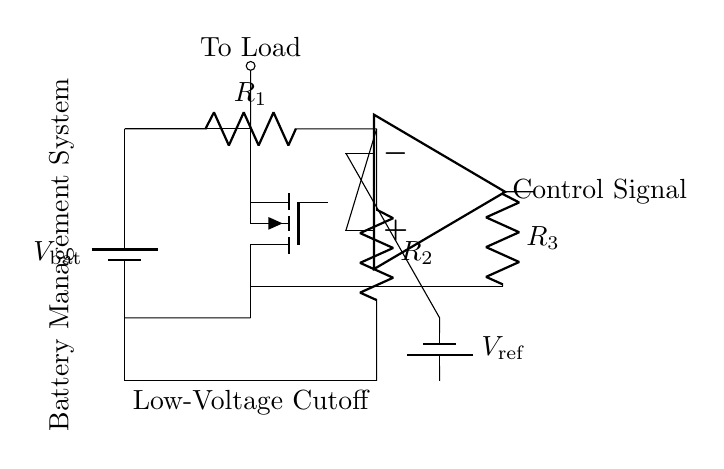What type of battery is used in this circuit? The circuit diagram indicates the use of a battery component, referred to as "V_bat," which is a generic identifier for batteries.
Answer: Battery What does R1 and R2 form together? R1 and R2 form a voltage divider, which helps to lower the voltage from the battery for comparison in the circuit.
Answer: Voltage divider What is the primary function of the mosfet in this circuit? The mosfet serves as an electronic switch that controls the connection to the load based on the voltage level detected.
Answer: Switch What signal does the op amp generate? The op amp generates a control signal based on the comparison between the voltage from the voltage divider and a reference voltage.
Answer: Control signal How many resistors are present in this circuit? There are three resistors designated as R1, R2, and R3 within the circuit diagram.
Answer: Three When is the load powered in this system? The load is powered when the voltage at the input of the op amp exceeds the reference voltage, causing the mosfet to turn on.
Answer: When voltage exceeds reference What is the role of the reference voltage in this circuit? The reference voltage is used by the op amp to determine whether to provide a control signal to turn the mosfet on or off based on the battery voltage.
Answer: Voltage reference 